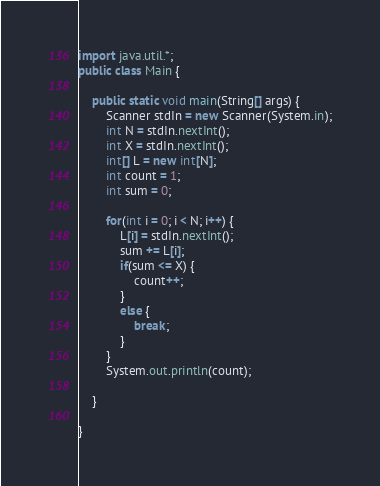<code> <loc_0><loc_0><loc_500><loc_500><_Java_>import java.util.*;
public class Main {

	public static void main(String[] args) {
		Scanner stdIn = new Scanner(System.in);
		int N = stdIn.nextInt();
		int X = stdIn.nextInt();
		int[] L = new int[N];
		int count = 1;
		int sum = 0;
		
		for(int i = 0; i < N; i++) {
			L[i] = stdIn.nextInt();
			sum += L[i];
			if(sum <= X) {
				count++;
			}
			else {
				break;
			}
		}
		System.out.println(count);

	}

}</code> 